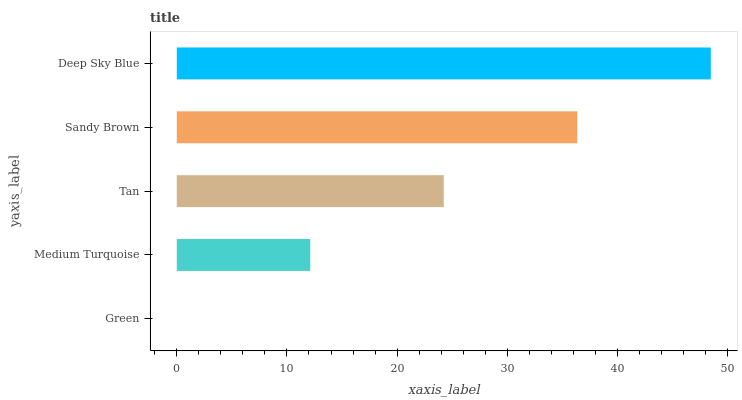Is Green the minimum?
Answer yes or no. Yes. Is Deep Sky Blue the maximum?
Answer yes or no. Yes. Is Medium Turquoise the minimum?
Answer yes or no. No. Is Medium Turquoise the maximum?
Answer yes or no. No. Is Medium Turquoise greater than Green?
Answer yes or no. Yes. Is Green less than Medium Turquoise?
Answer yes or no. Yes. Is Green greater than Medium Turquoise?
Answer yes or no. No. Is Medium Turquoise less than Green?
Answer yes or no. No. Is Tan the high median?
Answer yes or no. Yes. Is Tan the low median?
Answer yes or no. Yes. Is Medium Turquoise the high median?
Answer yes or no. No. Is Sandy Brown the low median?
Answer yes or no. No. 